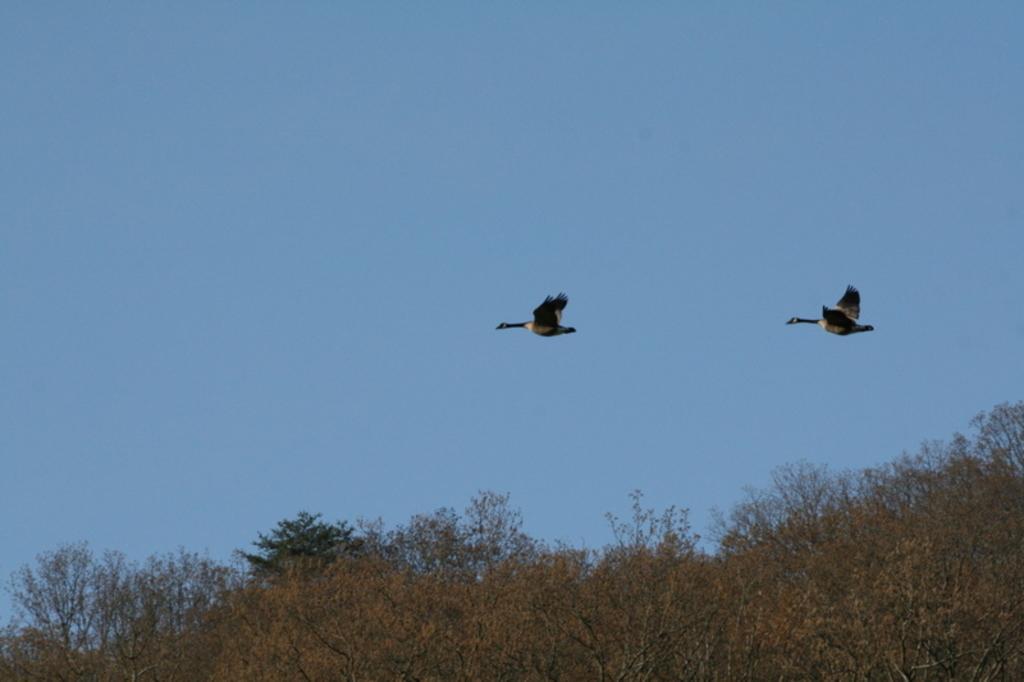Could you give a brief overview of what you see in this image? In this we can see two birds flying and at the bottom we can see trees and in the background we can see the sky. 